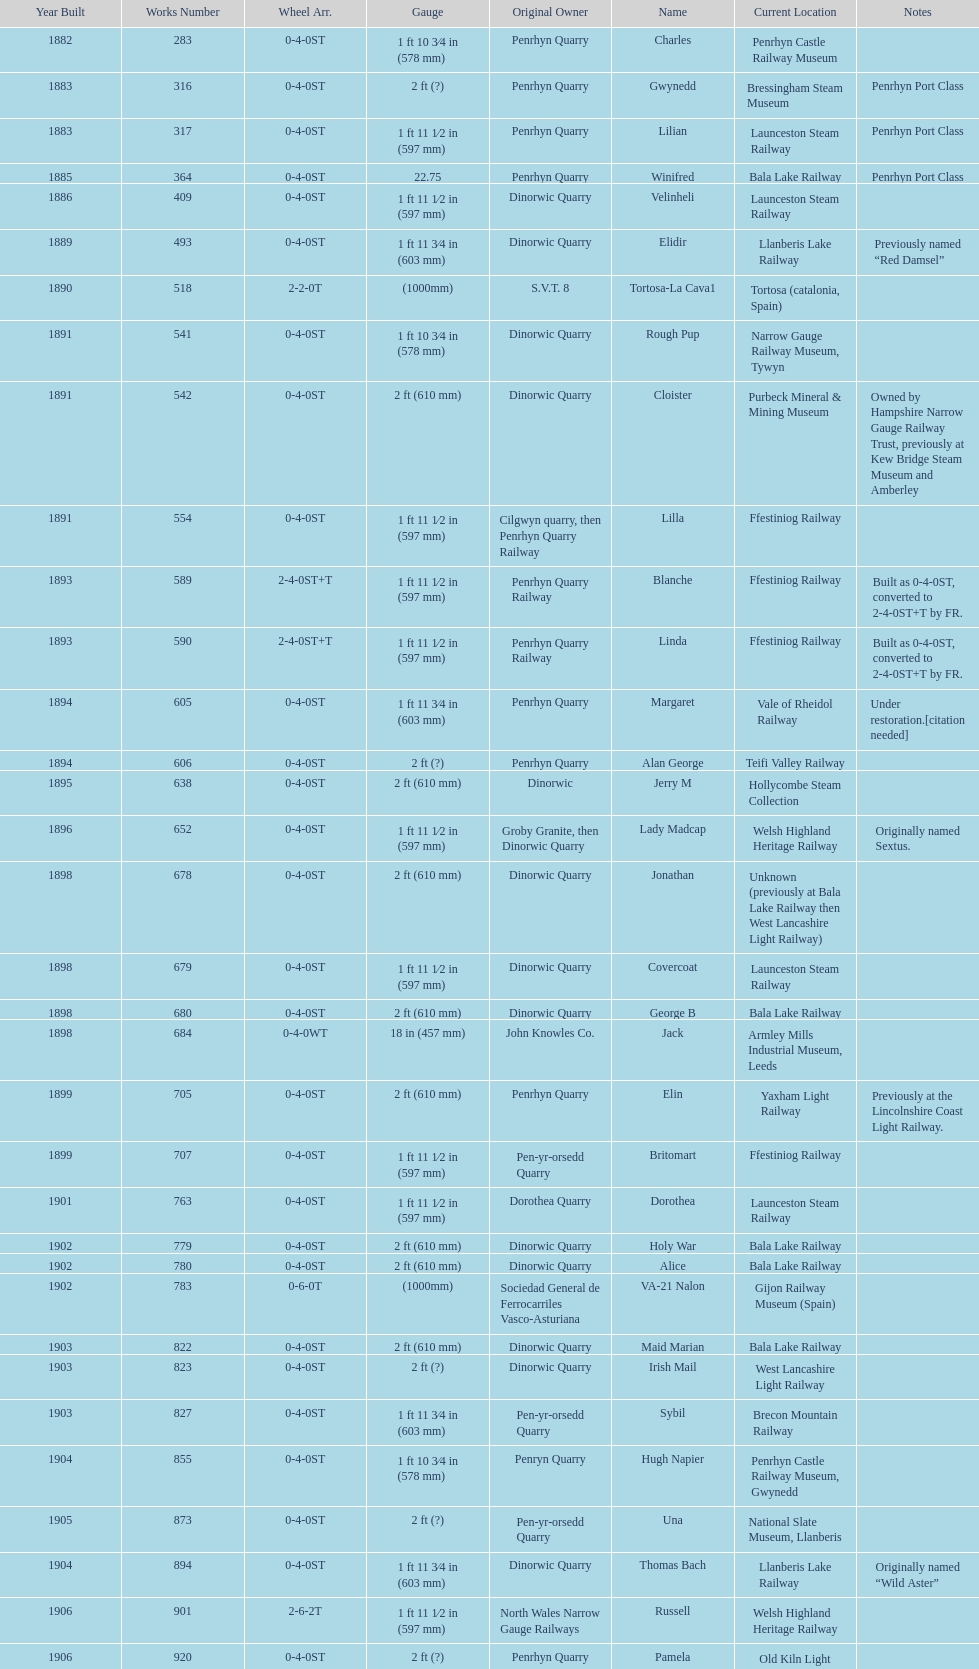What is the name of the last locomotive to be located at the bressingham steam museum? Gwynedd. 